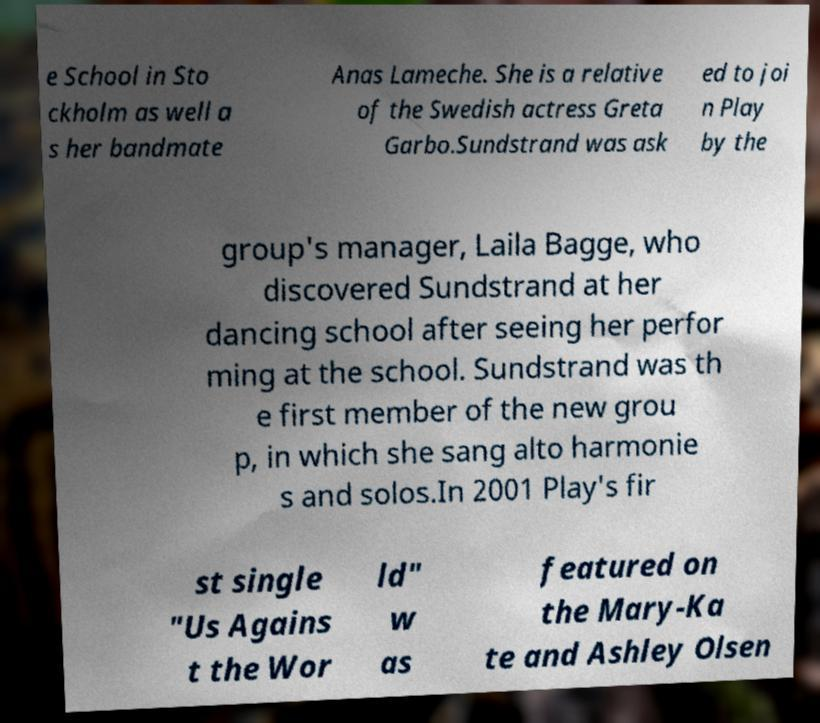Please identify and transcribe the text found in this image. e School in Sto ckholm as well a s her bandmate Anas Lameche. She is a relative of the Swedish actress Greta Garbo.Sundstrand was ask ed to joi n Play by the group's manager, Laila Bagge, who discovered Sundstrand at her dancing school after seeing her perfor ming at the school. Sundstrand was th e first member of the new grou p, in which she sang alto harmonie s and solos.In 2001 Play's fir st single "Us Agains t the Wor ld" w as featured on the Mary-Ka te and Ashley Olsen 